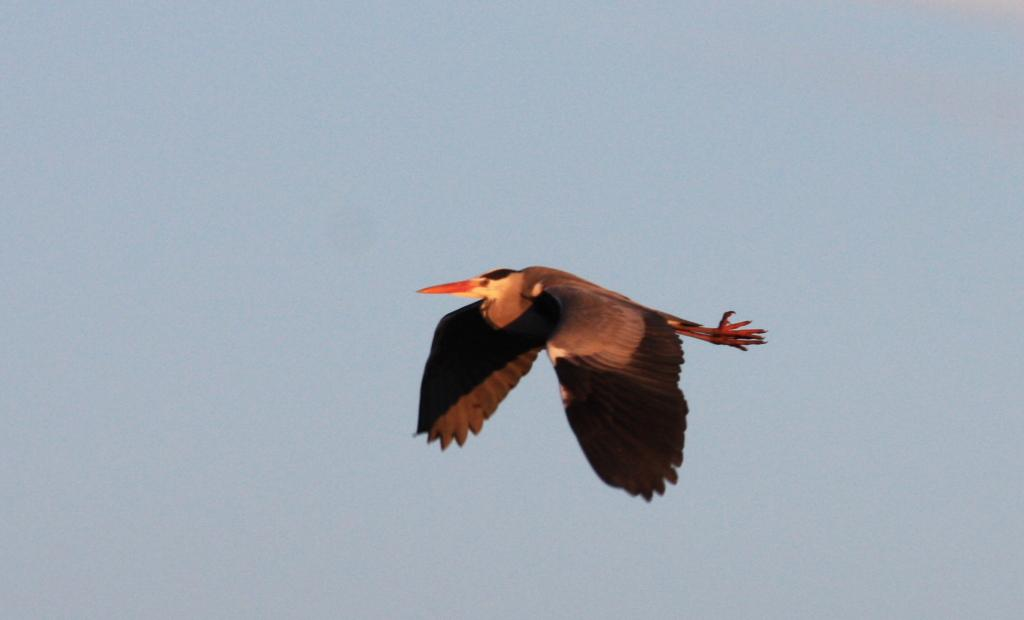What type of animal is in the image? There is a bird in the image. What is the bird doing in the image? The bird is flying in the air. What colors can be seen on the bird? The bird has black and brown colors. What color is the sky in the image? The sky is blue in the image. What is the bird's opinion on the current profit margins in the image? There is no indication in the image that the bird has an opinion on profit margins, as birds do not have the ability to form opinions on such matters. 